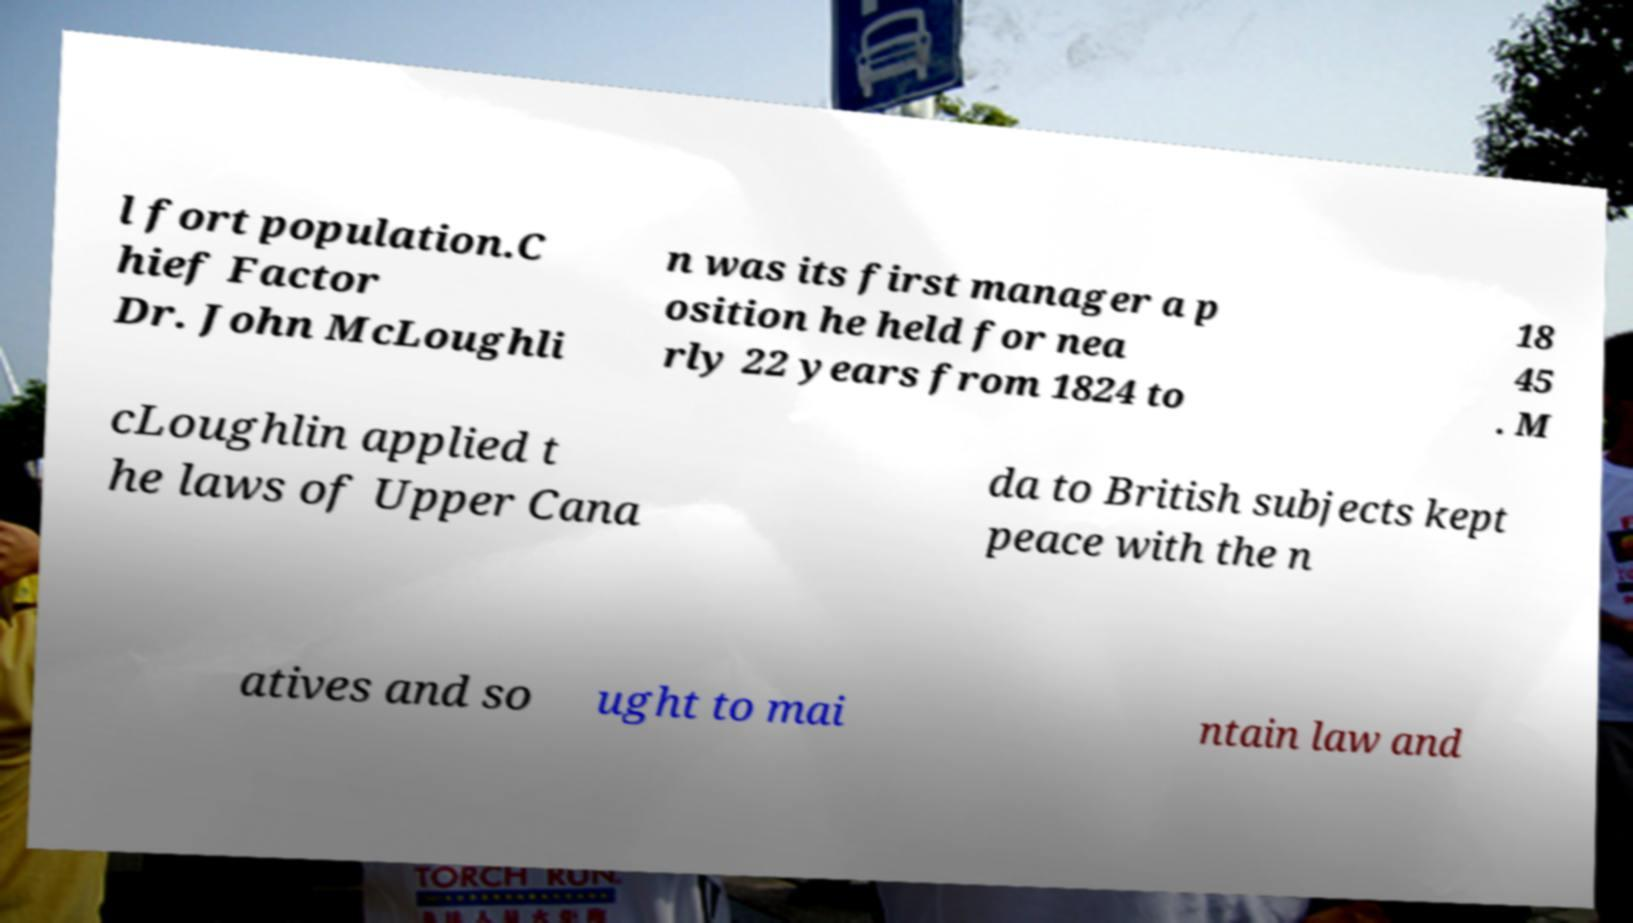What messages or text are displayed in this image? I need them in a readable, typed format. l fort population.C hief Factor Dr. John McLoughli n was its first manager a p osition he held for nea rly 22 years from 1824 to 18 45 . M cLoughlin applied t he laws of Upper Cana da to British subjects kept peace with the n atives and so ught to mai ntain law and 